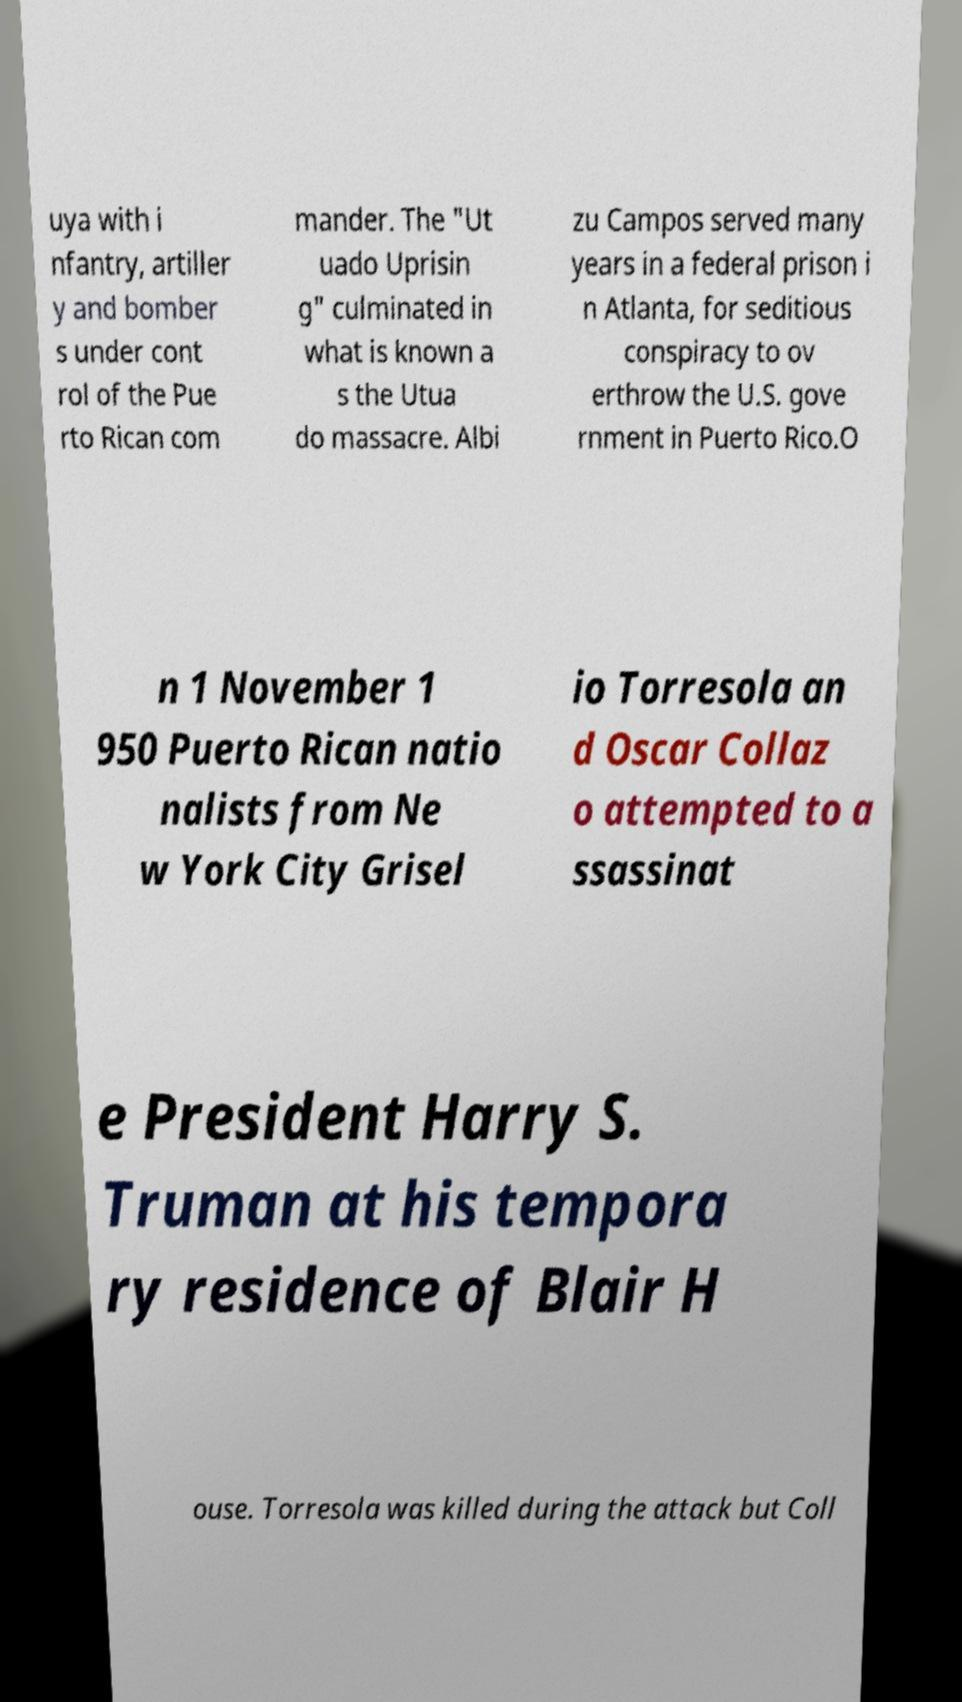I need the written content from this picture converted into text. Can you do that? uya with i nfantry, artiller y and bomber s under cont rol of the Pue rto Rican com mander. The "Ut uado Uprisin g" culminated in what is known a s the Utua do massacre. Albi zu Campos served many years in a federal prison i n Atlanta, for seditious conspiracy to ov erthrow the U.S. gove rnment in Puerto Rico.O n 1 November 1 950 Puerto Rican natio nalists from Ne w York City Grisel io Torresola an d Oscar Collaz o attempted to a ssassinat e President Harry S. Truman at his tempora ry residence of Blair H ouse. Torresola was killed during the attack but Coll 